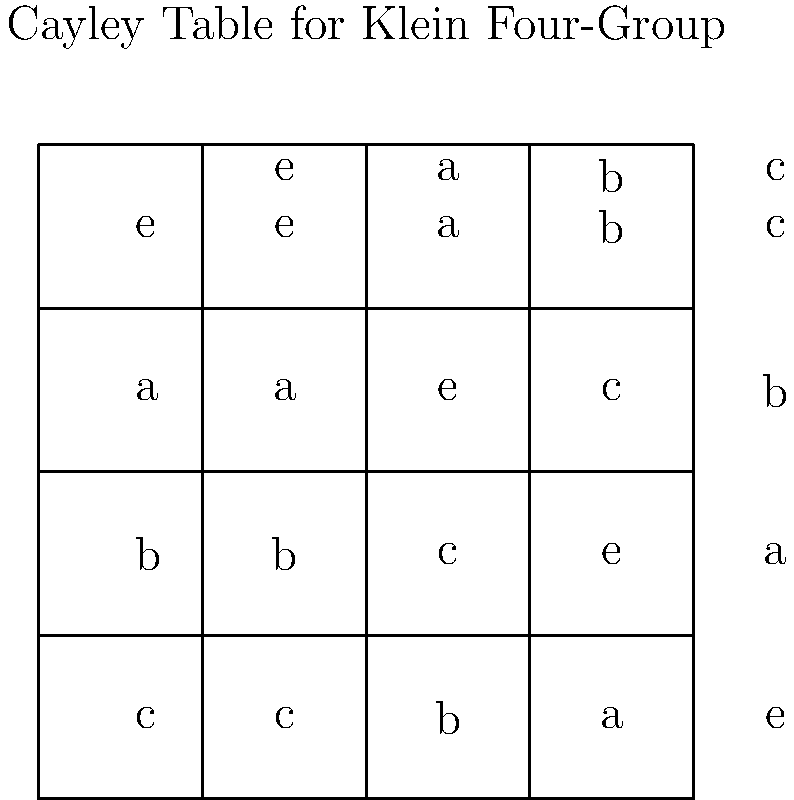As a business owner who understands the importance of efficient processes, consider the Cayley table for the Klein Four-Group shown above. If we compose the group elements $a$ and $b$, what is the resulting element? How does this relate to optimizing business operations? To find the composition of group elements $a$ and $b$ using the Cayley table, we follow these steps:

1. Locate the row corresponding to element $a$ (second row from the top).
2. Find the column corresponding to element $b$ (third column from the left).
3. The intersection of this row and column gives the result of the composition $a \circ b$.

In this case, we find that $a \circ b = c$.

This process relates to optimizing business operations in several ways:

1. Structured approach: Just as we use a structured table to find compositions quickly, businesses can create standardized processes to streamline operations.

2. Efficiency: The Cayley table allows for quick lookup of compositions, similar to how well-organized business systems can lead to faster decision-making and execution.

3. Predictability: The group structure ensures that compositions always yield a result within the group, much like how well-designed business processes should always lead to predictable outcomes.

4. Reversibility: In this group, every element has an inverse (e.g., $a \circ a = e$), which relates to the importance of having contingency plans or the ability to reverse decisions in business.

5. Associativity: The group operation is associative, $(a \circ b) \circ c = a \circ (b \circ c)$, which emphasizes the importance of consistent results regardless of the order of operations in business processes.

Understanding these mathematical concepts can provide insights into creating robust, efficient, and predictable business systems.
Answer: $c$ 